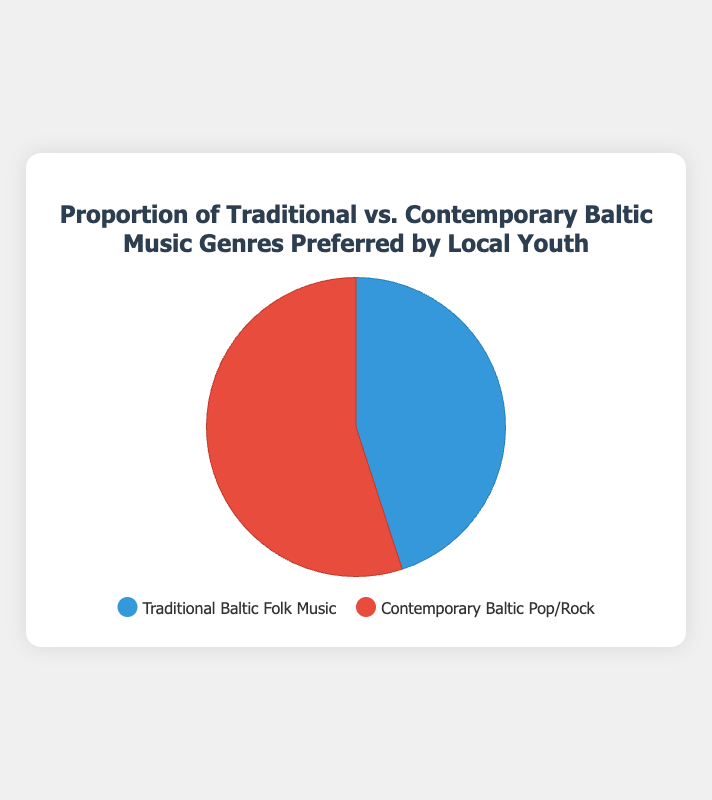What proportion of local youth prefers Contemporary Baltic Pop/Rock? The chart shows two sections with their respective proportions. The section for Contemporary Baltic Pop/Rock indicates a proportion of 55%.
Answer: 55% What is the difference in the proportions between Traditional Baltic Folk Music and Contemporary Baltic Pop/Rock? To find the difference, subtract the proportion of Traditional Baltic Folk Music from Contemporary Baltic Pop/Rock. 55% - 45% = 10%.
Answer: 10% Which music genre is preferred by a larger proportion of local youth? Compare the proportions of each genre. Contemporary Baltic Pop/Rock has a proportion of 55%, while Traditional Baltic Folk Music has 45%. Therefore, Contemporary Baltic Pop/Rock is preferred by a larger proportion.
Answer: Contemporary Baltic Pop/Rock What is the combined proportion of local youth who prefer either genre? Add the proportions of the two genres together. 45% + 55% = 100%.
Answer: 100% If you were to split the graph in half, which section would be larger? The section with the larger proportion would be larger if the graph were split in half. Contemporary Baltic Pop/Rock has a larger proportion (55%) compared to Traditional Baltic Folk Music (45%).
Answer: Contemporary Baltic Pop/Rock What colors are used to represent Traditional Baltic Folk Music and Contemporary Baltic Pop/Rock in the chart? Look at the legend to see the colors associated with each genre. Traditional Baltic Folk Music is represented by blue, and Contemporary Baltic Pop/Rock is represented by red.
Answer: Blue for Traditional Baltic Folk Music, Red for Contemporary Baltic Pop/Rock If you were to visually estimate, which portion of the pie chart looks larger? Observing the sizes of the colored portions in the pie chart indicates that the section for Contemporary Baltic Pop/Rock appears larger.
Answer: Contemporary Baltic Pop/Rock 